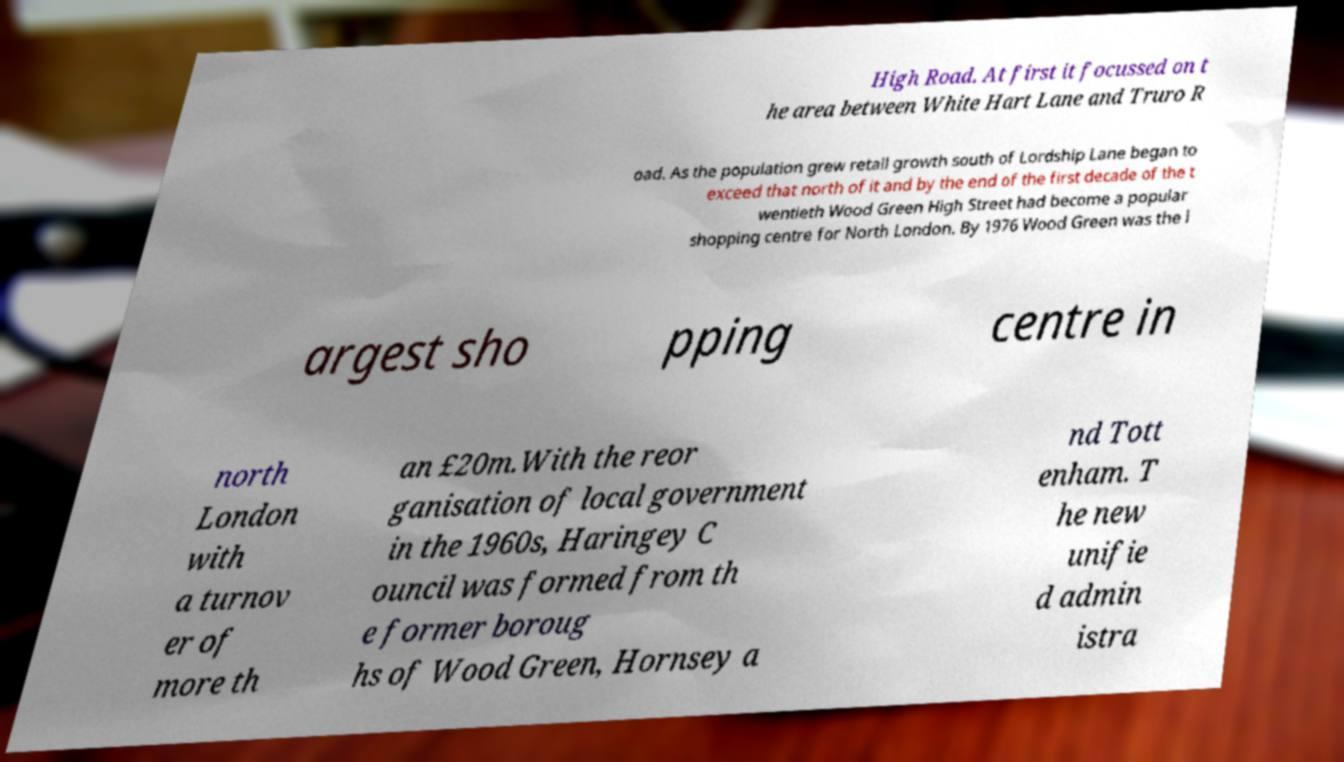Can you accurately transcribe the text from the provided image for me? High Road. At first it focussed on t he area between White Hart Lane and Truro R oad. As the population grew retail growth south of Lordship Lane began to exceed that north of it and by the end of the first decade of the t wentieth Wood Green High Street had become a popular shopping centre for North London. By 1976 Wood Green was the l argest sho pping centre in north London with a turnov er of more th an £20m.With the reor ganisation of local government in the 1960s, Haringey C ouncil was formed from th e former boroug hs of Wood Green, Hornsey a nd Tott enham. T he new unifie d admin istra 